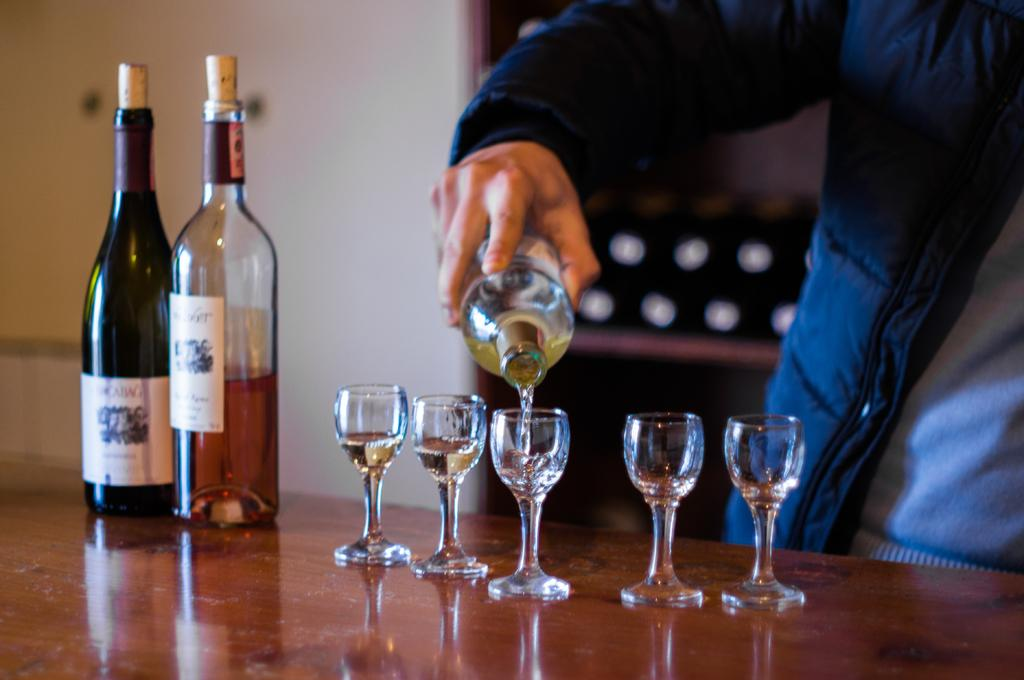What piece of furniture is present in the image? There is a table in the image. What items related to wine can be seen on the table? There are two wine bottles and wine glasses on the table. What action is the man performing in the image? The man is pouring wine into a wine glass. What type of business is being conducted in the image? There is no indication of a business being conducted in the image; it primarily features a man pouring wine into a wine glass. 